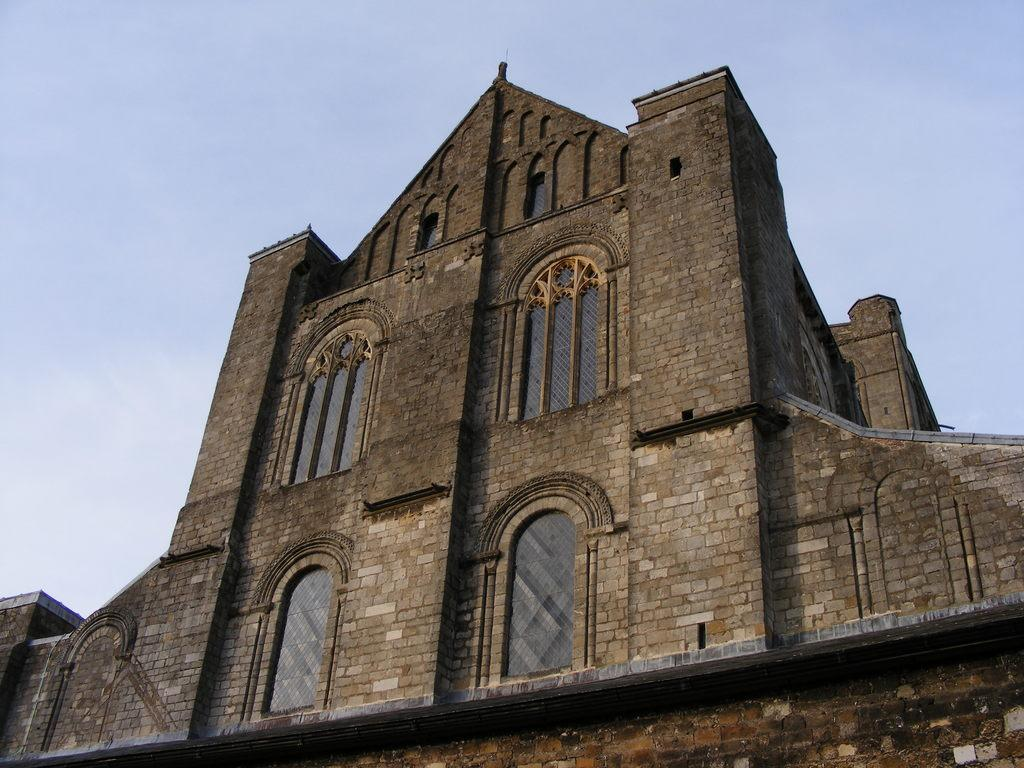What structure is present in the image? There is a building in the image. What feature can be observed on the building? The building has windows. What part of the natural environment is visible in the background of the image? The sky is visible in the background of the image. What type of question is being asked in the image? There is no question being asked in the image; it features a building with windows and a visible sky in the background. Can you see a field in the image? There is no field present in the image. 